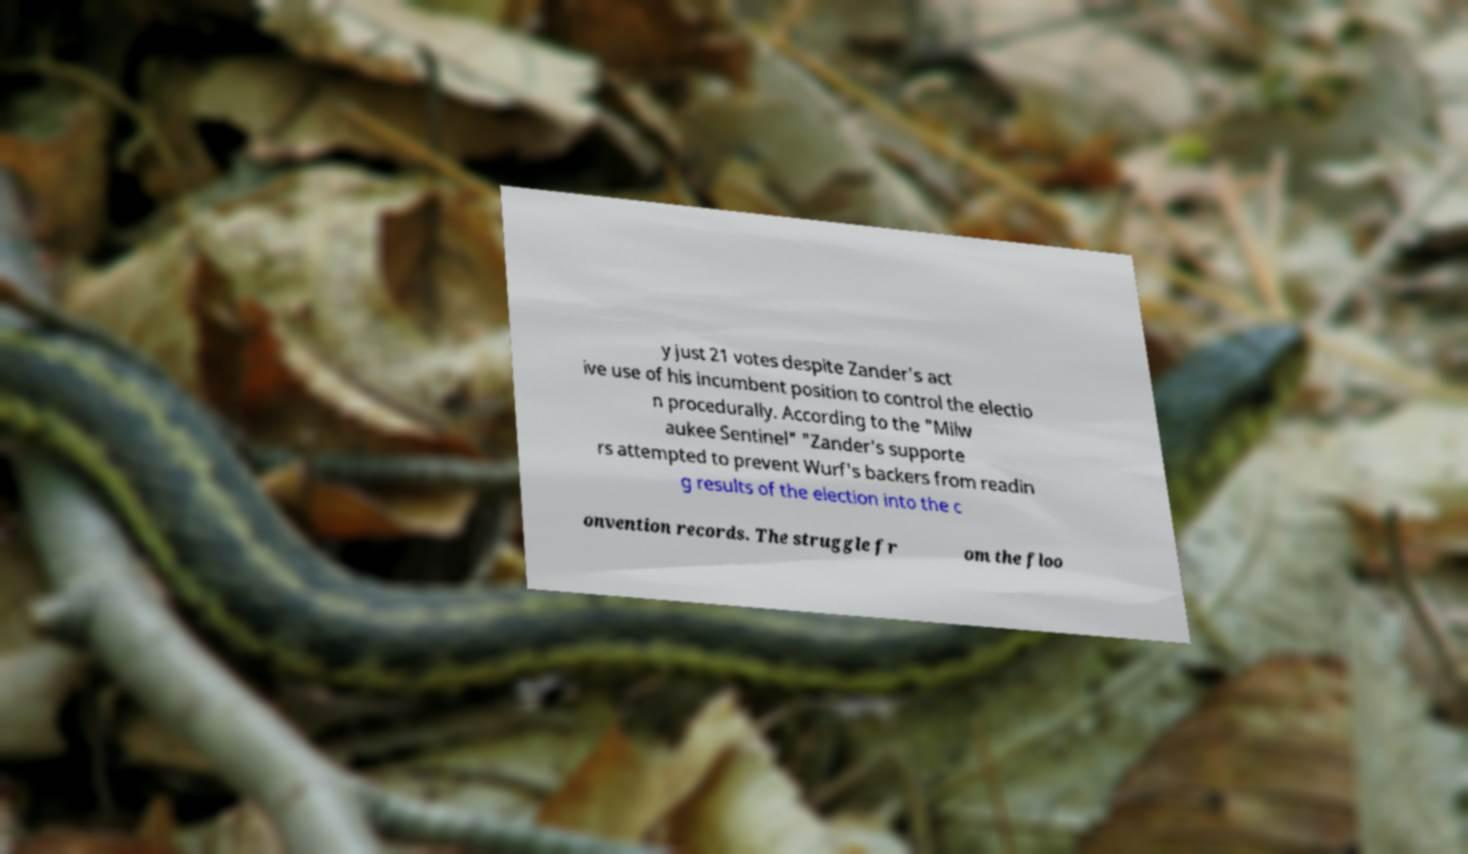Can you tell me more about the setting depicted behind the text? Behind the text, there seems to be a mix of natural elements, specifically dried and fallen leaves that may signify a location outdoors during autumn. The presence of the paper amongst the leaves might indicate that the document was discarded or lost outside. 